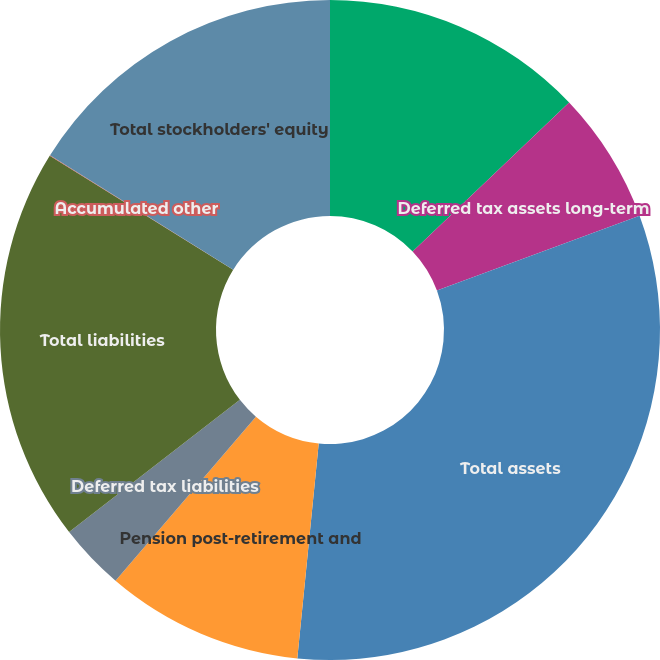Convert chart to OTSL. <chart><loc_0><loc_0><loc_500><loc_500><pie_chart><fcel>Other long-term assets<fcel>Deferred tax assets long-term<fcel>Total assets<fcel>Pension post-retirement and<fcel>Deferred tax liabilities<fcel>Total liabilities<fcel>Accumulated other<fcel>Total stockholders' equity<nl><fcel>12.9%<fcel>6.47%<fcel>32.21%<fcel>9.68%<fcel>3.25%<fcel>19.34%<fcel>0.03%<fcel>16.12%<nl></chart> 